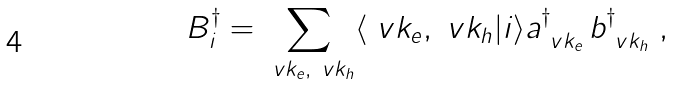Convert formula to latex. <formula><loc_0><loc_0><loc_500><loc_500>B _ { i } ^ { \dag } = \sum _ { \ v k _ { e } , \ v k _ { h } } \langle \ v k _ { e } , \ v k _ { h } | i \rangle a _ { \ v k _ { e } } ^ { \dag } \, b _ { \ v k _ { h } } ^ { \dag } \ ,</formula> 